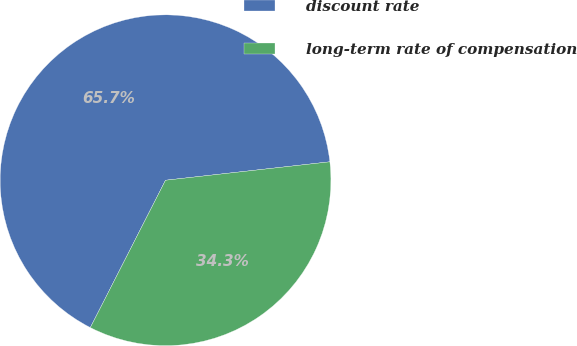<chart> <loc_0><loc_0><loc_500><loc_500><pie_chart><fcel>discount rate<fcel>long-term rate of compensation<nl><fcel>65.71%<fcel>34.29%<nl></chart> 